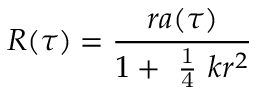<formula> <loc_0><loc_0><loc_500><loc_500>R ( \tau ) = \frac { r a ( \tau ) } { 1 + \frac { 1 } { 4 } k r ^ { 2 } }</formula> 